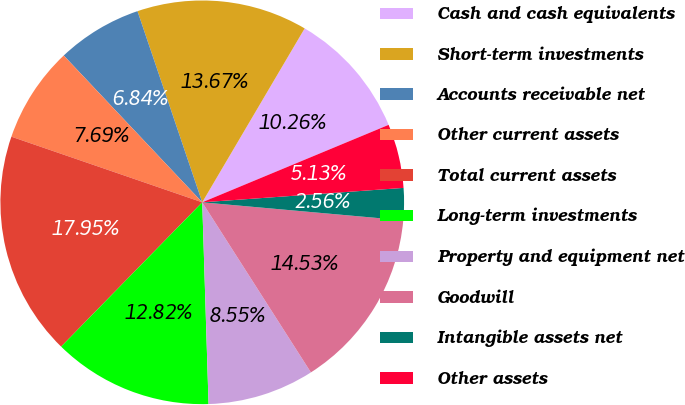<chart> <loc_0><loc_0><loc_500><loc_500><pie_chart><fcel>Cash and cash equivalents<fcel>Short-term investments<fcel>Accounts receivable net<fcel>Other current assets<fcel>Total current assets<fcel>Long-term investments<fcel>Property and equipment net<fcel>Goodwill<fcel>Intangible assets net<fcel>Other assets<nl><fcel>10.26%<fcel>13.67%<fcel>6.84%<fcel>7.69%<fcel>17.95%<fcel>12.82%<fcel>8.55%<fcel>14.53%<fcel>2.56%<fcel>5.13%<nl></chart> 